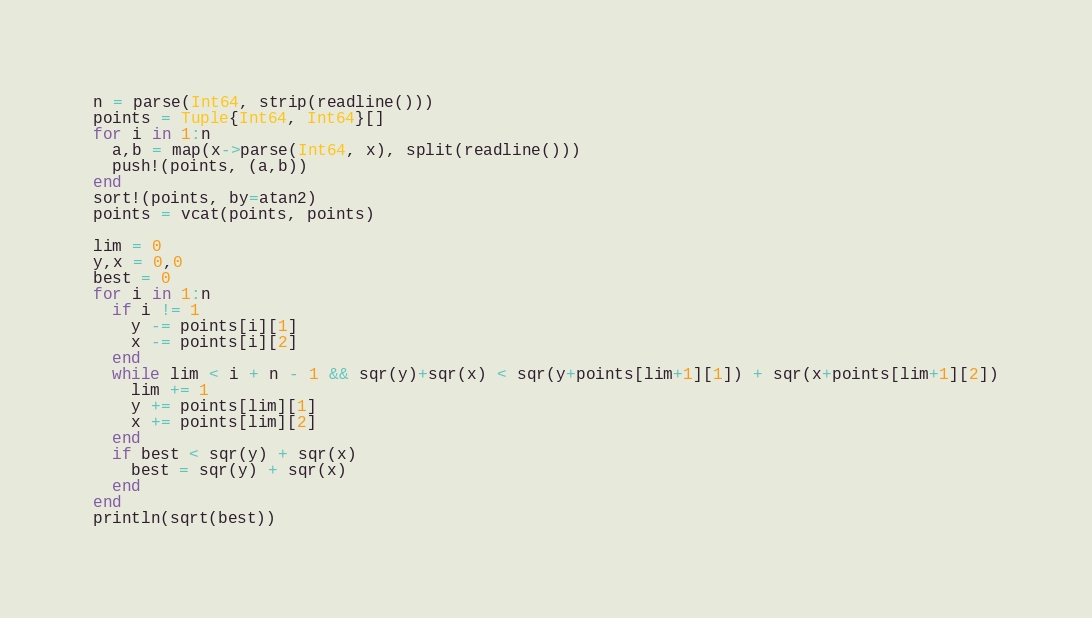Convert code to text. <code><loc_0><loc_0><loc_500><loc_500><_Julia_>n = parse(Int64, strip(readline()))
points = Tuple{Int64, Int64}[]
for i in 1:n
  a,b = map(x->parse(Int64, x), split(readline()))
  push!(points, (a,b))
end
sort!(points, by=atan2)
points = vcat(points, points)

lim = 0
y,x = 0,0
best = 0
for i in 1:n
  if i != 1
    y -= points[i][1]
    x -= points[i][2]
  end
  while lim < i + n - 1 && sqr(y)+sqr(x) < sqr(y+points[lim+1][1]) + sqr(x+points[lim+1][2])
    lim += 1
    y += points[lim][1]
    x += points[lim][2]
  end
  if best < sqr(y) + sqr(x)
    best = sqr(y) + sqr(x)
  end
end
println(sqrt(best))</code> 